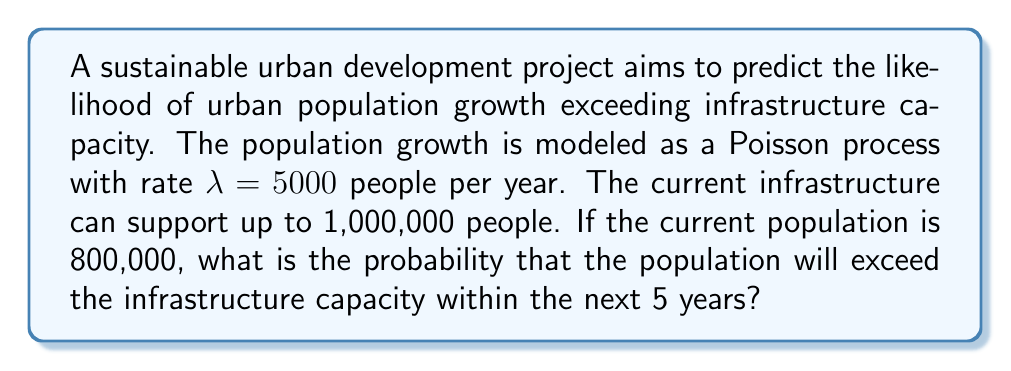Can you solve this math problem? To solve this problem, we'll follow these steps:

1) First, we need to calculate how many more people the city can accommodate before reaching capacity:
   $1,000,000 - 800,000 = 200,000$ people

2) We're dealing with a Poisson process with rate $\lambda = 5000$ people per year over a 5-year period.
   The mean number of new people over 5 years is:
   $\mu = \lambda \cdot t = 5000 \cdot 5 = 25,000$ people

3) We want to find the probability that the population growth exceeds 200,000 in 5 years.
   This is equivalent to finding the probability that a Poisson random variable with mean 25,000 is greater than 200,000.

4) For large values of $\mu$, the Poisson distribution can be approximated by a normal distribution with mean $\mu$ and standard deviation $\sqrt{\mu}$.

5) We can standardize this to a standard normal distribution:
   $Z = \frac{X - \mu}{\sqrt{\mu}} = \frac{200,000 - 25,000}{\sqrt{25,000}} \approx 350.71$

6) The probability we're looking for is $P(X > 200,000) = P(Z > 350.71)$

7) This probability is extremely small and effectively zero for all practical purposes.

8) Using a standard normal table or calculator, we find:
   $P(Z > 350.71) \approx 0$

Therefore, the probability of the population exceeding the infrastructure capacity within 5 years is effectively zero.
Answer: $\approx 0$ 